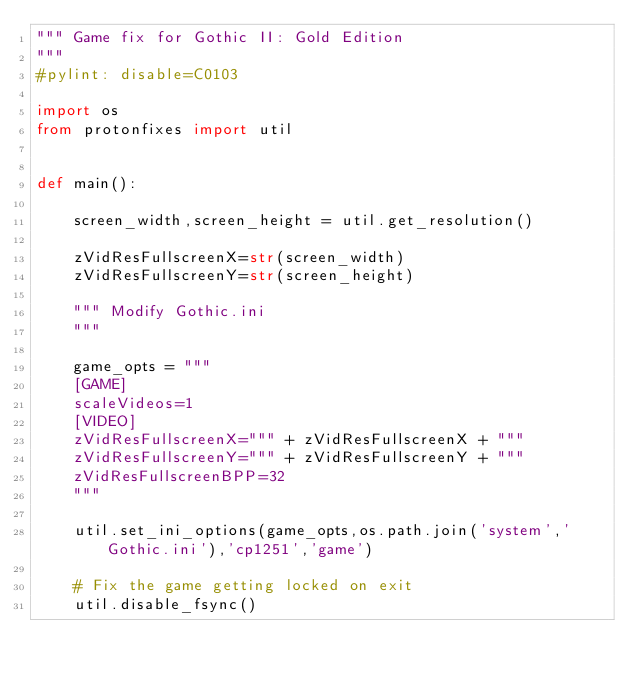<code> <loc_0><loc_0><loc_500><loc_500><_Python_>""" Game fix for Gothic II: Gold Edition
"""
#pylint: disable=C0103

import os
from protonfixes import util


def main():

    screen_width,screen_height = util.get_resolution()

    zVidResFullscreenX=str(screen_width)
    zVidResFullscreenY=str(screen_height)

    """ Modify Gothic.ini
    """

    game_opts = """
    [GAME]
    scaleVideos=1
    [VIDEO]
    zVidResFullscreenX=""" + zVidResFullscreenX + """
    zVidResFullscreenY=""" + zVidResFullscreenY + """
    zVidResFullscreenBPP=32
    """

    util.set_ini_options(game_opts,os.path.join('system','Gothic.ini'),'cp1251','game')

    # Fix the game getting locked on exit
    util.disable_fsync()
</code> 